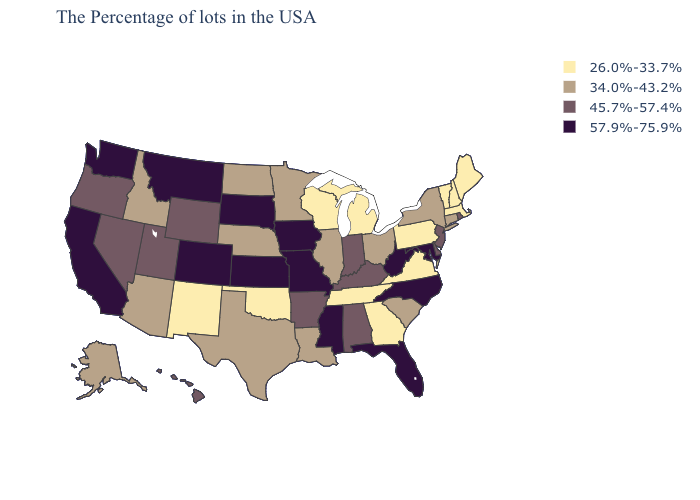Does Georgia have the lowest value in the USA?
Keep it brief. Yes. What is the value of Washington?
Short answer required. 57.9%-75.9%. What is the highest value in states that border Idaho?
Keep it brief. 57.9%-75.9%. What is the value of North Dakota?
Be succinct. 34.0%-43.2%. Name the states that have a value in the range 45.7%-57.4%?
Be succinct. Rhode Island, New Jersey, Delaware, Kentucky, Indiana, Alabama, Arkansas, Wyoming, Utah, Nevada, Oregon, Hawaii. Which states have the lowest value in the MidWest?
Be succinct. Michigan, Wisconsin. What is the highest value in the USA?
Write a very short answer. 57.9%-75.9%. What is the highest value in states that border Florida?
Answer briefly. 45.7%-57.4%. Does Michigan have a lower value than Louisiana?
Write a very short answer. Yes. Among the states that border Alabama , which have the highest value?
Write a very short answer. Florida, Mississippi. Does Wisconsin have the lowest value in the USA?
Give a very brief answer. Yes. Which states have the lowest value in the USA?
Be succinct. Maine, Massachusetts, New Hampshire, Vermont, Pennsylvania, Virginia, Georgia, Michigan, Tennessee, Wisconsin, Oklahoma, New Mexico. What is the value of New Jersey?
Concise answer only. 45.7%-57.4%. What is the lowest value in the South?
Short answer required. 26.0%-33.7%. 